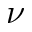Convert formula to latex. <formula><loc_0><loc_0><loc_500><loc_500>\nu</formula> 